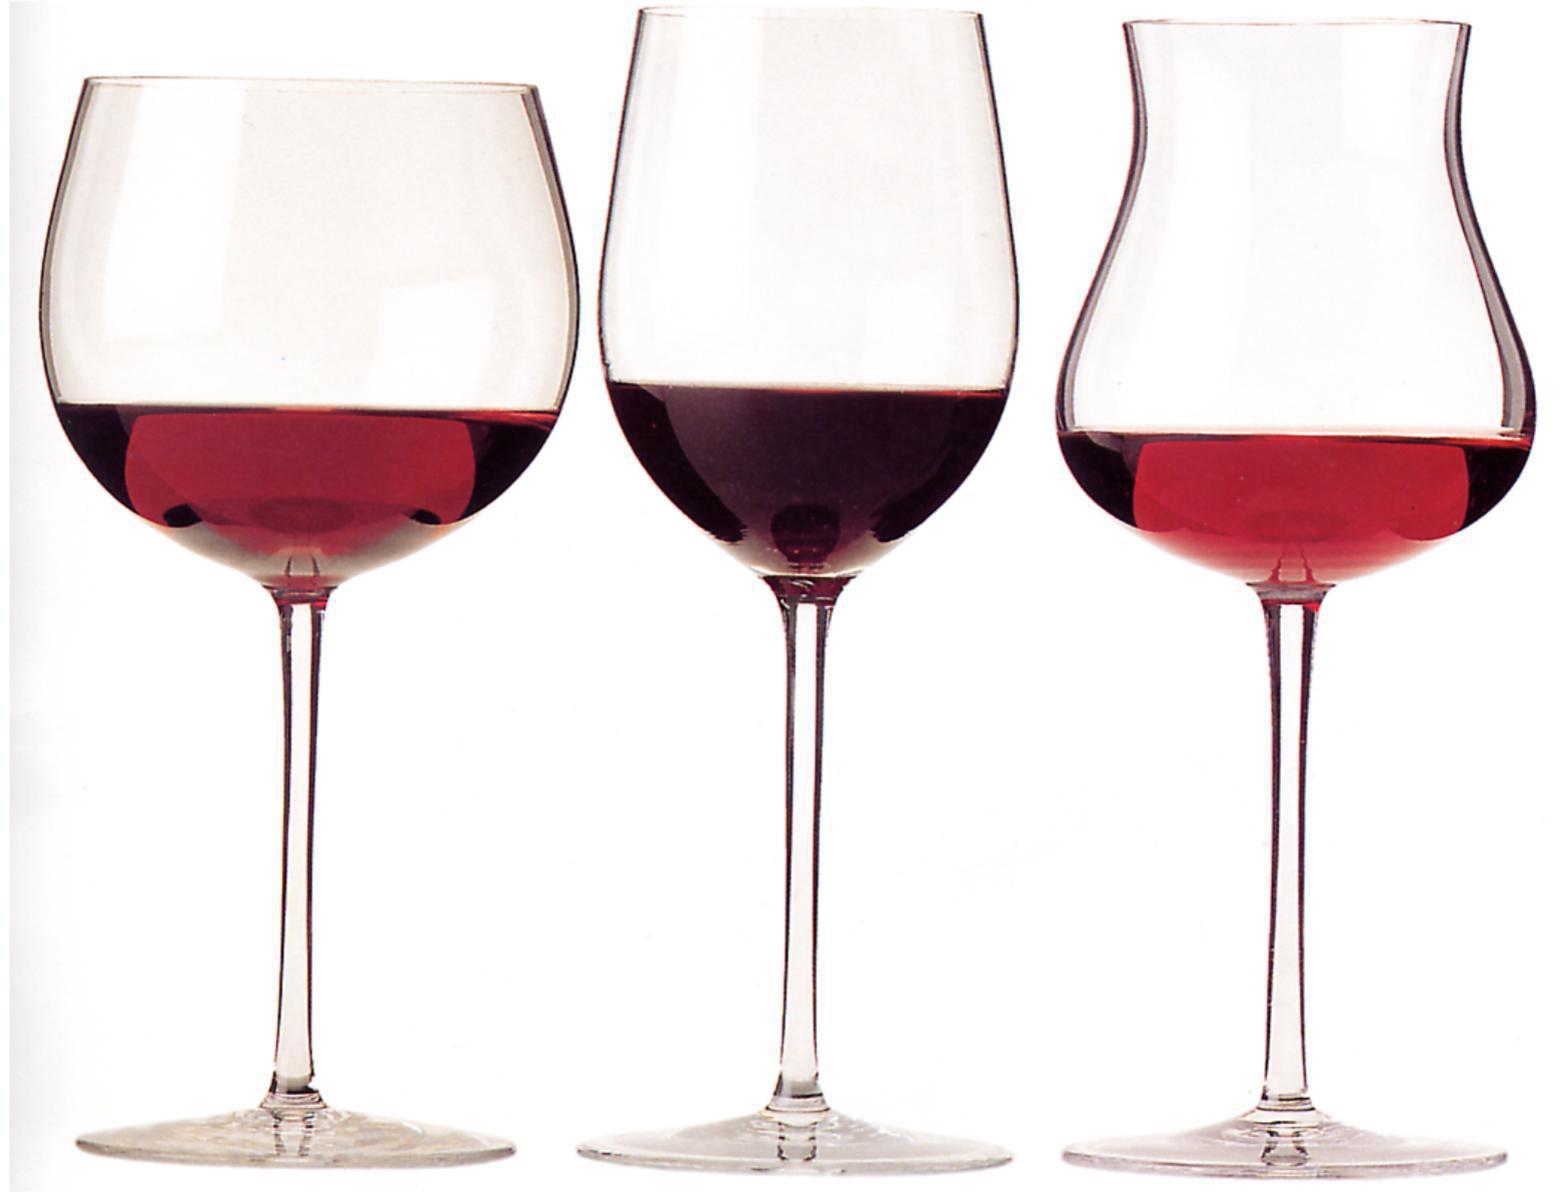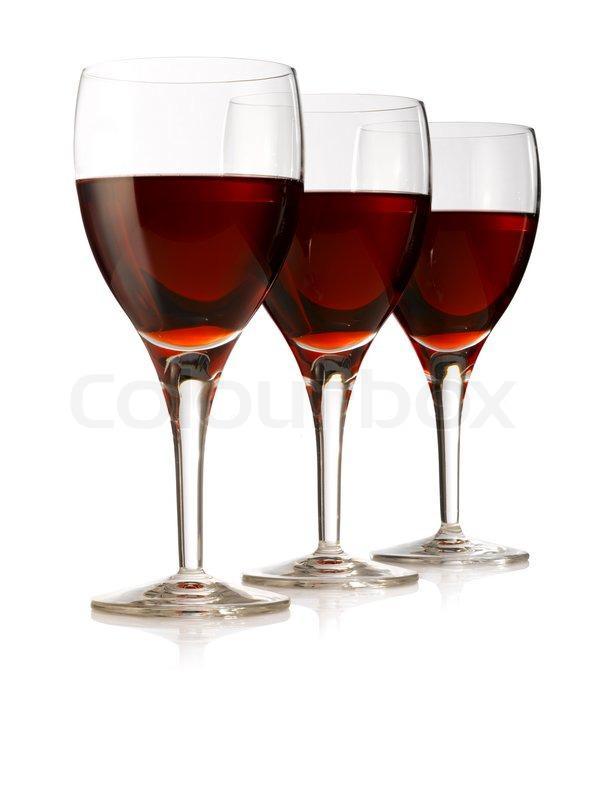The first image is the image on the left, the second image is the image on the right. Considering the images on both sides, is "There is at least two wine glasses in the right image." valid? Answer yes or no. Yes. The first image is the image on the left, the second image is the image on the right. Examine the images to the left and right. Is the description "The same number of glasses of red wine are shown in both images" accurate? Answer yes or no. Yes. 